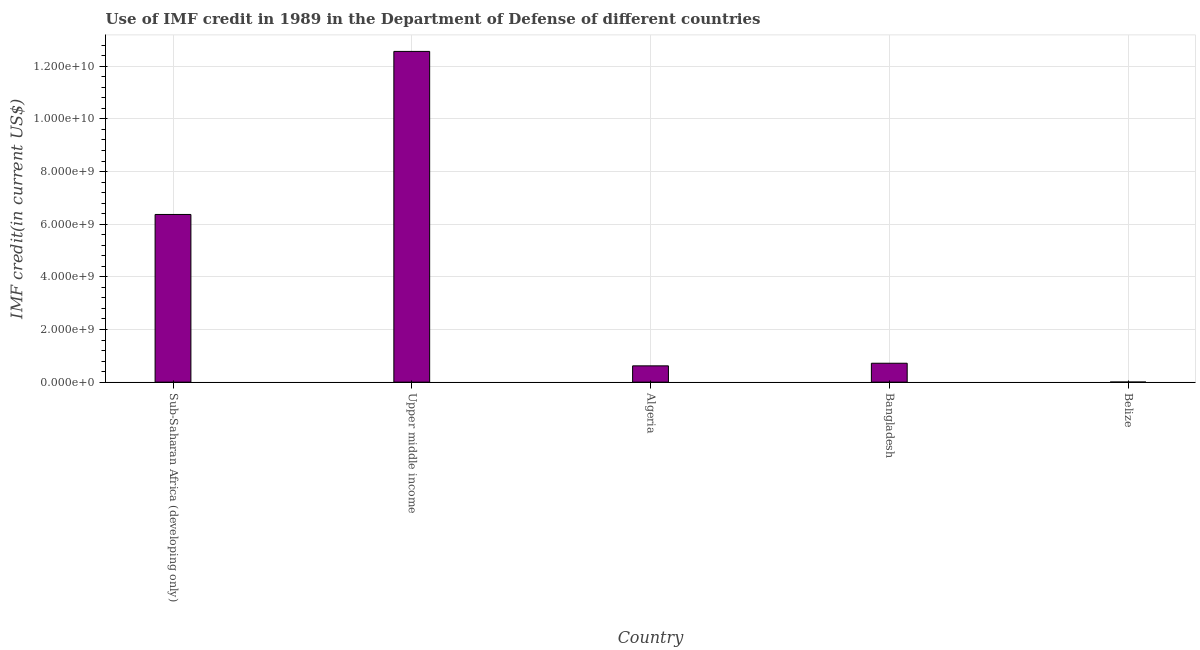What is the title of the graph?
Your answer should be very brief. Use of IMF credit in 1989 in the Department of Defense of different countries. What is the label or title of the X-axis?
Keep it short and to the point. Country. What is the label or title of the Y-axis?
Your response must be concise. IMF credit(in current US$). What is the use of imf credit in dod in Bangladesh?
Offer a terse response. 7.19e+08. Across all countries, what is the maximum use of imf credit in dod?
Your response must be concise. 1.26e+1. Across all countries, what is the minimum use of imf credit in dod?
Your response must be concise. 3.31e+06. In which country was the use of imf credit in dod maximum?
Keep it short and to the point. Upper middle income. In which country was the use of imf credit in dod minimum?
Provide a short and direct response. Belize. What is the sum of the use of imf credit in dod?
Your answer should be compact. 2.03e+1. What is the difference between the use of imf credit in dod in Belize and Upper middle income?
Ensure brevity in your answer.  -1.26e+1. What is the average use of imf credit in dod per country?
Provide a succinct answer. 4.06e+09. What is the median use of imf credit in dod?
Ensure brevity in your answer.  7.19e+08. What is the ratio of the use of imf credit in dod in Bangladesh to that in Sub-Saharan Africa (developing only)?
Your answer should be very brief. 0.11. What is the difference between the highest and the second highest use of imf credit in dod?
Your response must be concise. 6.19e+09. What is the difference between the highest and the lowest use of imf credit in dod?
Your answer should be very brief. 1.26e+1. In how many countries, is the use of imf credit in dod greater than the average use of imf credit in dod taken over all countries?
Keep it short and to the point. 2. What is the difference between two consecutive major ticks on the Y-axis?
Offer a terse response. 2.00e+09. What is the IMF credit(in current US$) in Sub-Saharan Africa (developing only)?
Your response must be concise. 6.37e+09. What is the IMF credit(in current US$) of Upper middle income?
Ensure brevity in your answer.  1.26e+1. What is the IMF credit(in current US$) of Algeria?
Your answer should be very brief. 6.19e+08. What is the IMF credit(in current US$) in Bangladesh?
Keep it short and to the point. 7.19e+08. What is the IMF credit(in current US$) in Belize?
Offer a very short reply. 3.31e+06. What is the difference between the IMF credit(in current US$) in Sub-Saharan Africa (developing only) and Upper middle income?
Provide a short and direct response. -6.19e+09. What is the difference between the IMF credit(in current US$) in Sub-Saharan Africa (developing only) and Algeria?
Offer a terse response. 5.75e+09. What is the difference between the IMF credit(in current US$) in Sub-Saharan Africa (developing only) and Bangladesh?
Provide a short and direct response. 5.65e+09. What is the difference between the IMF credit(in current US$) in Sub-Saharan Africa (developing only) and Belize?
Keep it short and to the point. 6.37e+09. What is the difference between the IMF credit(in current US$) in Upper middle income and Algeria?
Give a very brief answer. 1.19e+1. What is the difference between the IMF credit(in current US$) in Upper middle income and Bangladesh?
Your answer should be compact. 1.18e+1. What is the difference between the IMF credit(in current US$) in Upper middle income and Belize?
Make the answer very short. 1.26e+1. What is the difference between the IMF credit(in current US$) in Algeria and Bangladesh?
Your answer should be compact. -9.97e+07. What is the difference between the IMF credit(in current US$) in Algeria and Belize?
Your answer should be compact. 6.16e+08. What is the difference between the IMF credit(in current US$) in Bangladesh and Belize?
Offer a terse response. 7.15e+08. What is the ratio of the IMF credit(in current US$) in Sub-Saharan Africa (developing only) to that in Upper middle income?
Give a very brief answer. 0.51. What is the ratio of the IMF credit(in current US$) in Sub-Saharan Africa (developing only) to that in Algeria?
Offer a terse response. 10.29. What is the ratio of the IMF credit(in current US$) in Sub-Saharan Africa (developing only) to that in Bangladesh?
Offer a very short reply. 8.87. What is the ratio of the IMF credit(in current US$) in Sub-Saharan Africa (developing only) to that in Belize?
Provide a short and direct response. 1923.04. What is the ratio of the IMF credit(in current US$) in Upper middle income to that in Algeria?
Ensure brevity in your answer.  20.3. What is the ratio of the IMF credit(in current US$) in Upper middle income to that in Bangladesh?
Provide a succinct answer. 17.49. What is the ratio of the IMF credit(in current US$) in Upper middle income to that in Belize?
Provide a succinct answer. 3792.74. What is the ratio of the IMF credit(in current US$) in Algeria to that in Bangladesh?
Make the answer very short. 0.86. What is the ratio of the IMF credit(in current US$) in Algeria to that in Belize?
Make the answer very short. 186.79. What is the ratio of the IMF credit(in current US$) in Bangladesh to that in Belize?
Provide a short and direct response. 216.89. 